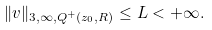Convert formula to latex. <formula><loc_0><loc_0><loc_500><loc_500>\| v \| _ { 3 , \infty , Q ^ { + } ( z _ { 0 } , R ) } \leq L < + \infty .</formula> 